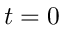Convert formula to latex. <formula><loc_0><loc_0><loc_500><loc_500>t = 0</formula> 